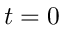Convert formula to latex. <formula><loc_0><loc_0><loc_500><loc_500>t = 0</formula> 